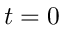Convert formula to latex. <formula><loc_0><loc_0><loc_500><loc_500>t = 0</formula> 